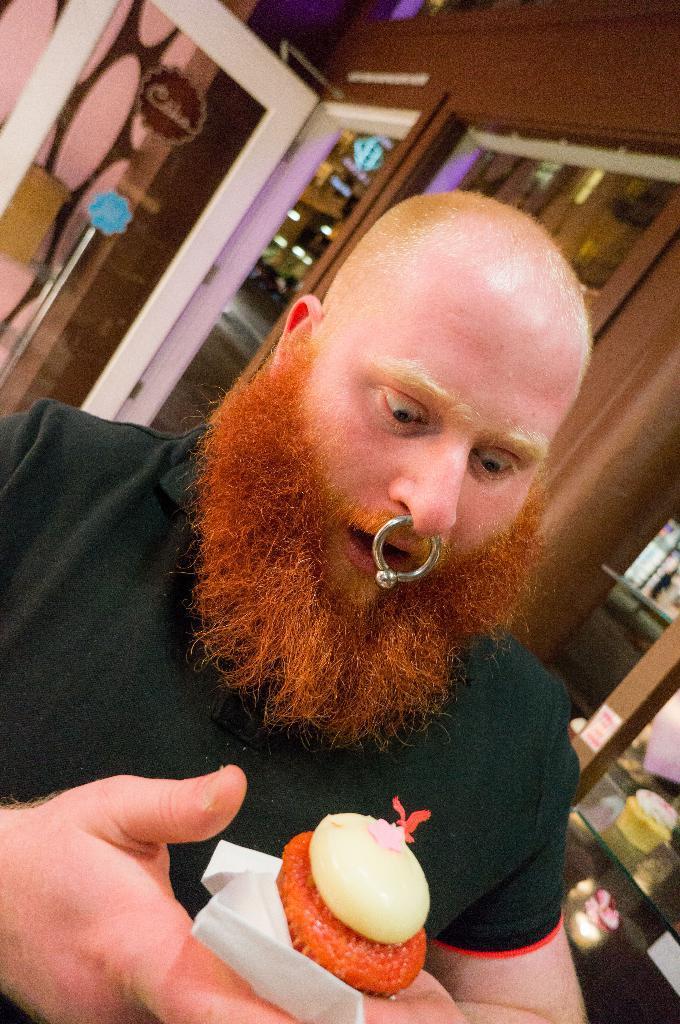How would you summarize this image in a sentence or two? In this image we can see a man holding some food with tissue papers. On the backside we can see a table with an object on it, some stickers, a door and a wall. 